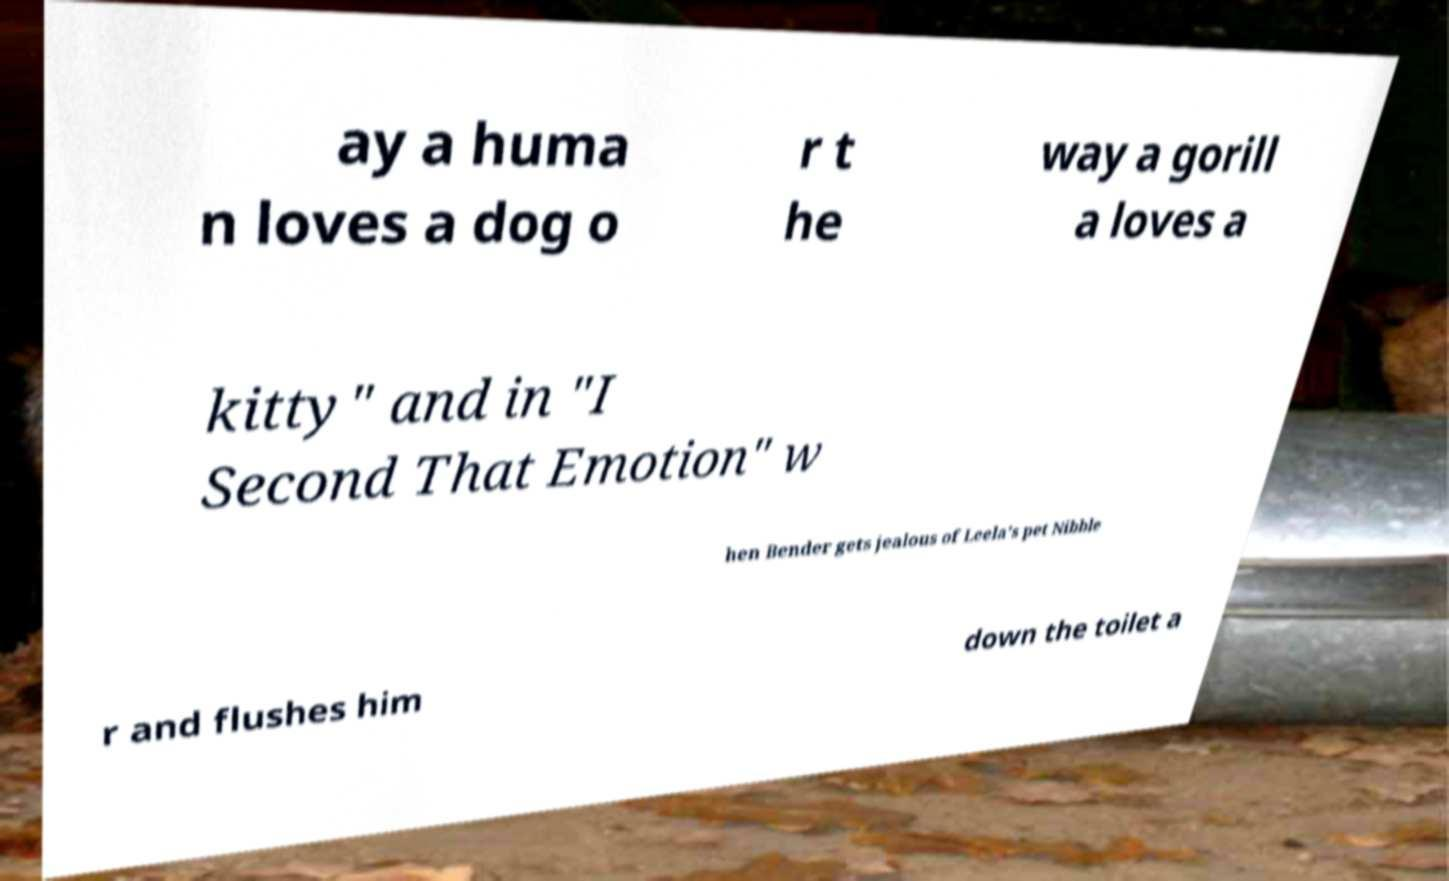Please identify and transcribe the text found in this image. ay a huma n loves a dog o r t he way a gorill a loves a kitty" and in "I Second That Emotion" w hen Bender gets jealous of Leela’s pet Nibble r and flushes him down the toilet a 